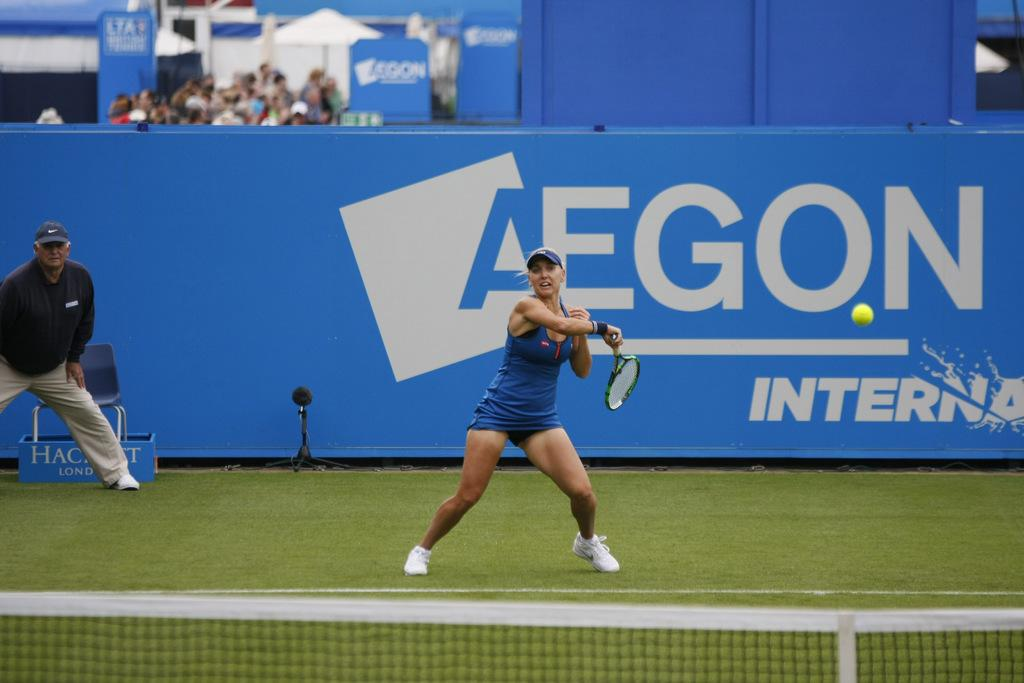Who is the main subject in the image? There is a woman in the image. What is the woman holding in the image? The woman is holding a racket. Where is the woman playing in the image? The woman is playing in a court. What separates the two sides of the court in the image? There is a net in the image. What can be seen hanging in the background of the image? There is a banner in the image. Are there any other people visible in the image? Yes, there are people in the background of the image. How many jellyfish are swimming in the court in the image? There are no jellyfish present in the image; it features a woman playing with a racket in a court. What advice does the woman's grandfather give her during the game in the image? There is no mention of a grandfather or any advice-giving in the image; it simply shows a woman playing with a racket in a court. 